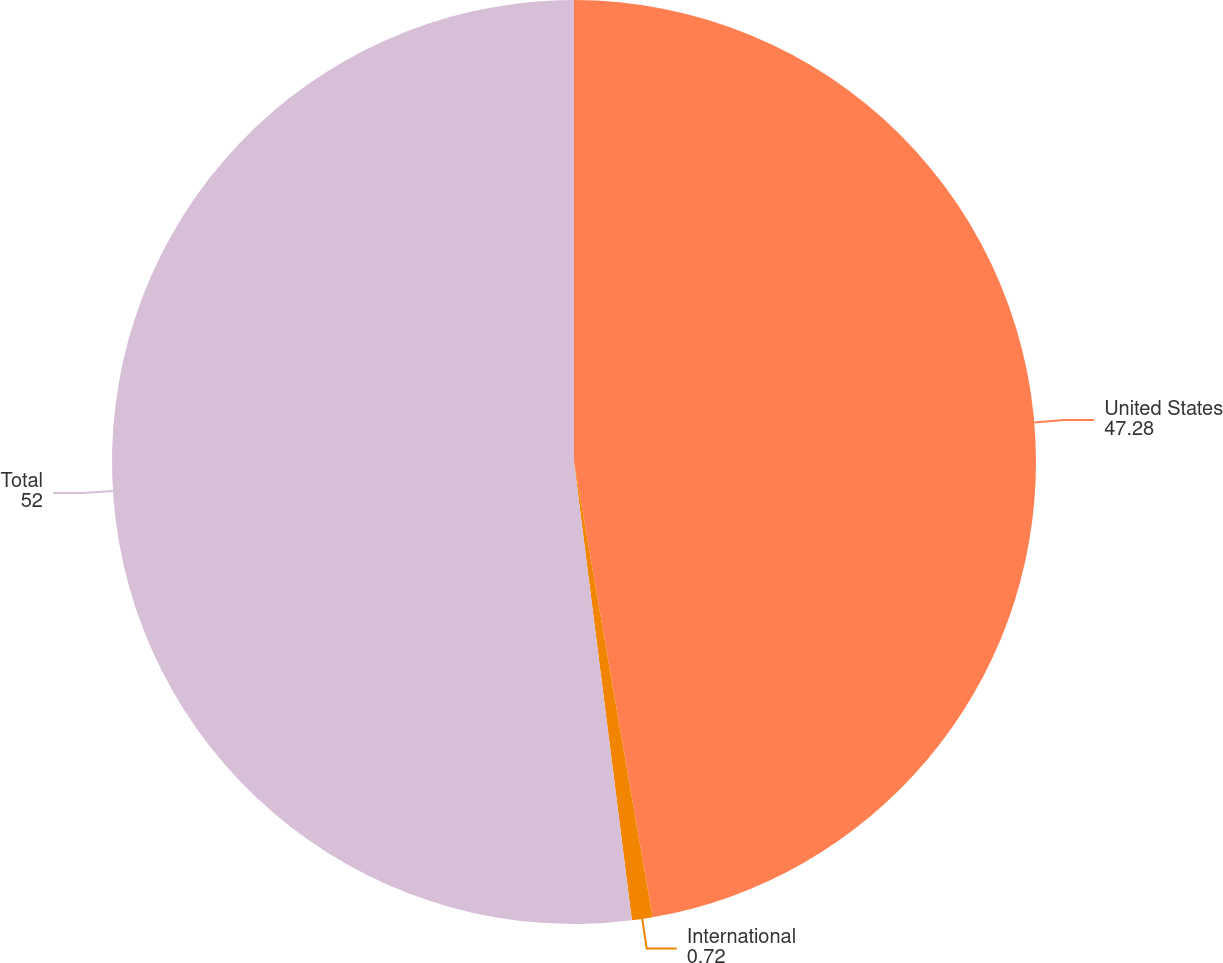Convert chart. <chart><loc_0><loc_0><loc_500><loc_500><pie_chart><fcel>United States<fcel>International<fcel>Total<nl><fcel>47.28%<fcel>0.72%<fcel>52.0%<nl></chart> 